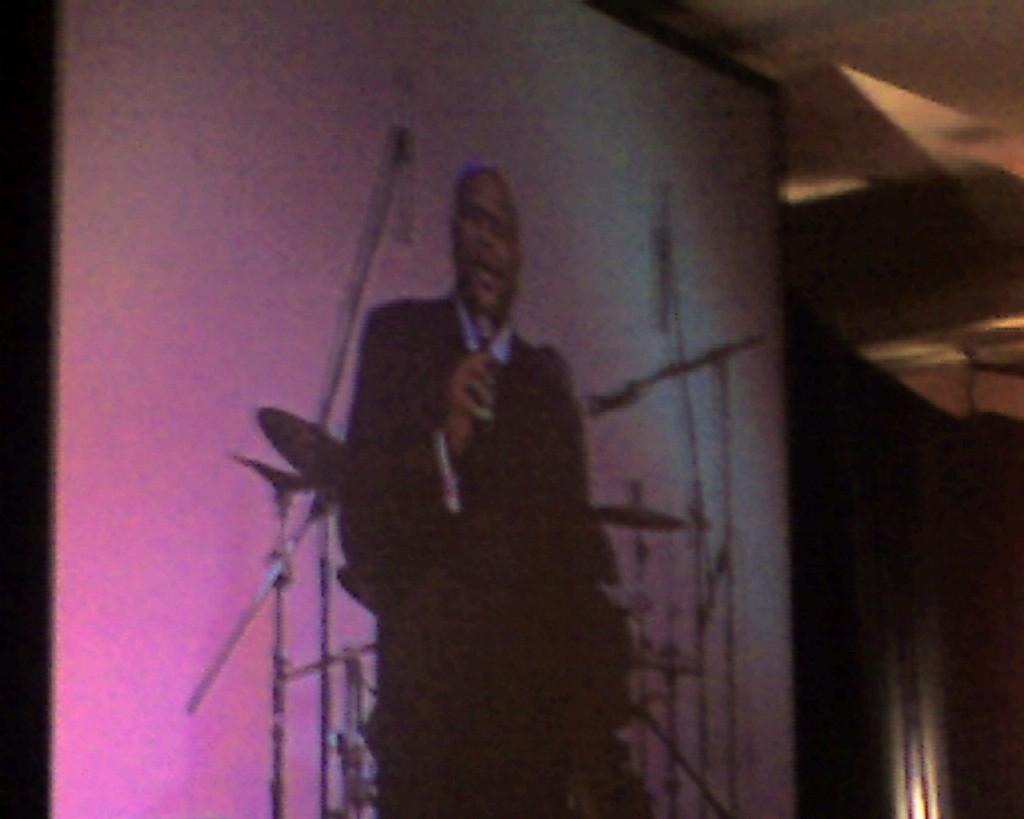Can you describe this image briefly? In this image there is a screen on that screen there is a man standing, in the background there are musical instruments. 